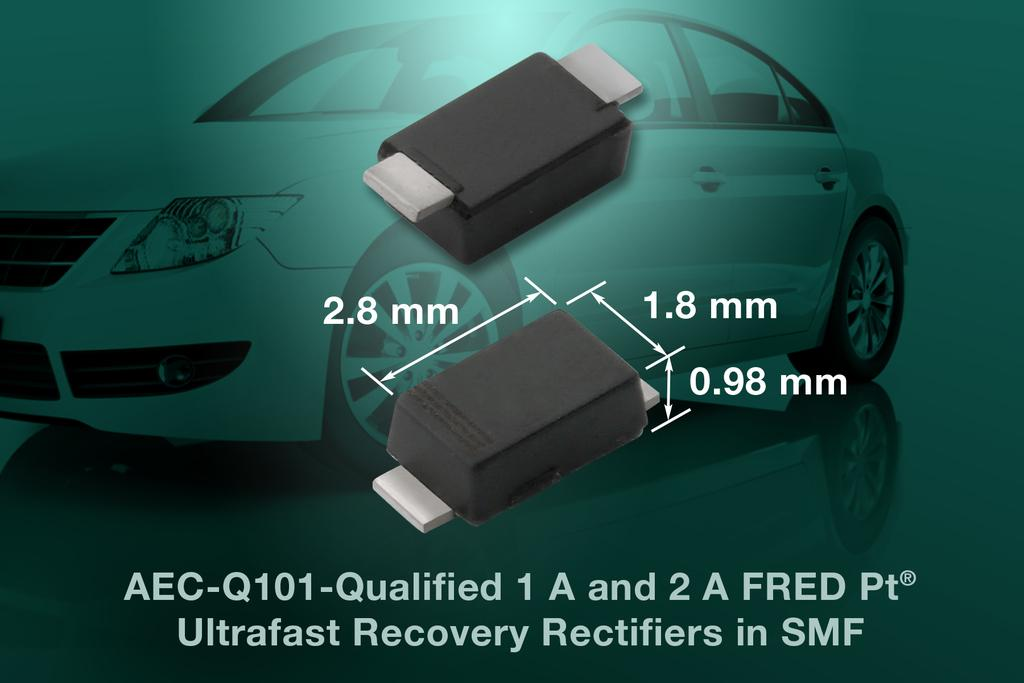What can be seen hanging on the wall in the image? There is a poster in the image. What electronic devices are visible in the image? There are pen drives in the image. What mode of transportation is present in the image? There is a car in the image. What is written on the poster in the image? There is text written on the poster. Can you tell me how many horses are depicted on the poster? There is no horse depicted on the poster; it only contains text. What type of pig can be seen reading a book in the image? There is no pig present in the image, let alone one reading a book. 